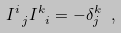<formula> <loc_0><loc_0><loc_500><loc_500>I ^ { i } _ { \ j } I ^ { k } _ { \ i } = - \delta ^ { k } _ { j } \ ,</formula> 